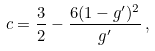Convert formula to latex. <formula><loc_0><loc_0><loc_500><loc_500>c = \frac { 3 } { 2 } - \frac { 6 ( 1 - g ^ { \prime } ) ^ { 2 } } { g ^ { \prime } } \, ,</formula> 